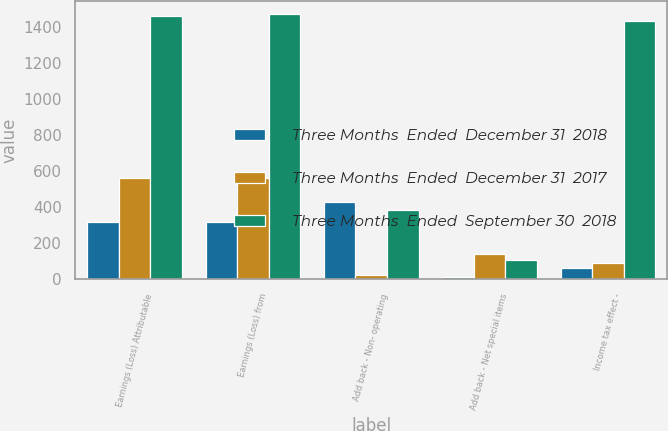Convert chart to OTSL. <chart><loc_0><loc_0><loc_500><loc_500><stacked_bar_chart><ecel><fcel>Earnings (Loss) Attributable<fcel>Earnings (Loss) from<fcel>Add back - Non- operating<fcel>Add back - Net special items<fcel>Income tax effect -<nl><fcel>Three Months  Ended  December 31  2018<fcel>316<fcel>316<fcel>429<fcel>15<fcel>60<nl><fcel>Three Months  Ended  December 31  2017<fcel>562<fcel>562<fcel>25<fcel>142<fcel>88<nl><fcel>Three Months  Ended  September 30  2018<fcel>1460<fcel>1468<fcel>386<fcel>106<fcel>1430<nl></chart> 